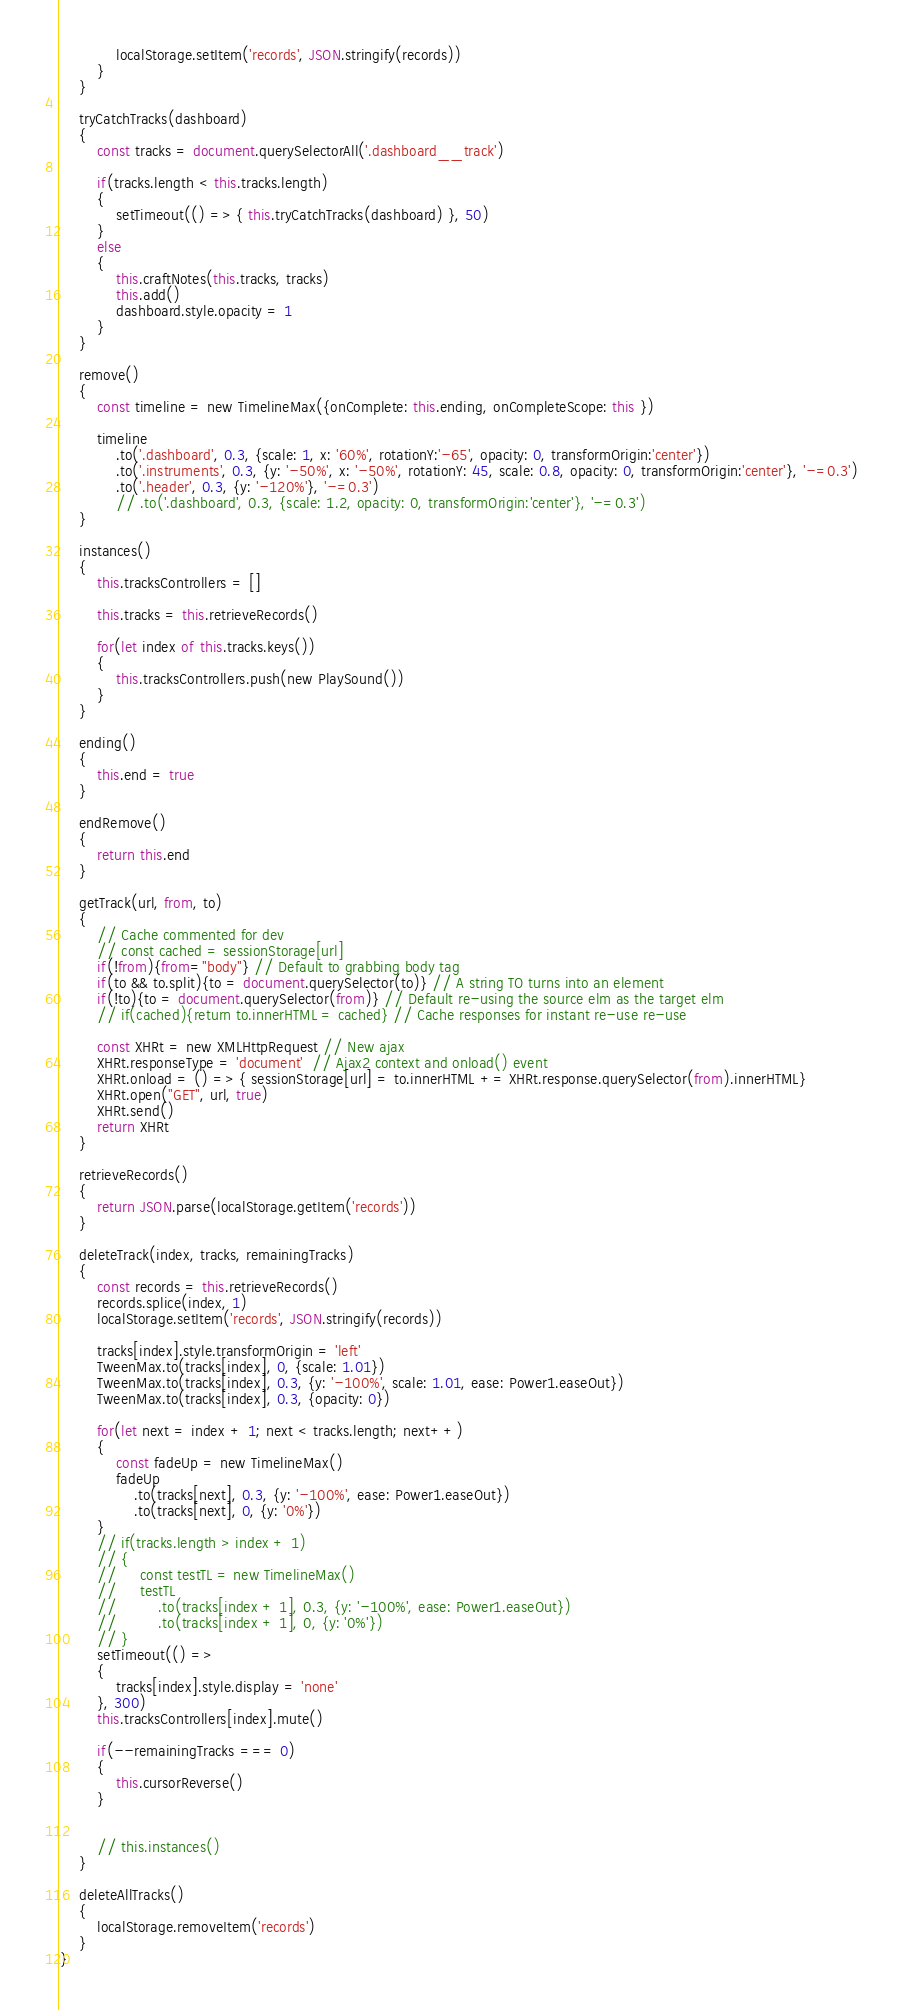Convert code to text. <code><loc_0><loc_0><loc_500><loc_500><_JavaScript_>            localStorage.setItem('records', JSON.stringify(records))
        }
    }

    tryCatchTracks(dashboard)
    {
        const tracks = document.querySelectorAll('.dashboard__track')

        if(tracks.length < this.tracks.length)
        {
            setTimeout(() => { this.tryCatchTracks(dashboard) }, 50)
        }
        else
        {
            this.craftNotes(this.tracks, tracks)
            this.add()
            dashboard.style.opacity = 1
        }
    }

    remove()
    {
        const timeline = new TimelineMax({onComplete: this.ending, onCompleteScope: this })
        
        timeline
            .to('.dashboard', 0.3, {scale: 1, x: '60%', rotationY:'-65', opacity: 0, transformOrigin:'center'})
            .to('.instruments', 0.3, {y: '-50%', x: '-50%', rotationY: 45, scale: 0.8, opacity: 0, transformOrigin:'center'}, '-=0.3')
            .to('.header', 0.3, {y: '-120%'}, '-=0.3')
            // .to('.dashboard', 0.3, {scale: 1.2, opacity: 0, transformOrigin:'center'}, '-=0.3')
    }

    instances()
    {
        this.tracksControllers = []
        
        this.tracks = this.retrieveRecords()

        for(let index of this.tracks.keys())
        {
            this.tracksControllers.push(new PlaySound())
        }
    }

    ending()
    {
        this.end = true
    }

    endRemove()
    {
        return this.end
    }

    getTrack(url, from, to)
	{
		// Cache commented for dev
		// const cached = sessionStorage[url]
		if(!from){from="body"} // Default to grabbing body tag
		if(to && to.split){to = document.querySelector(to)} // A string TO turns into an element
		if(!to){to = document.querySelector(from)} // Default re-using the source elm as the target elm
		// if(cached){return to.innerHTML = cached} // Cache responses for instant re-use re-use

		const XHRt = new XMLHttpRequest // New ajax
		XHRt.responseType = 'document'  // Ajax2 context and onload() event
		XHRt.onload = () => { sessionStorage[url] = to.innerHTML += XHRt.response.querySelector(from).innerHTML}
		XHRt.open("GET", url, true)
		XHRt.send()
		return XHRt
    }

    retrieveRecords()
	{
		return JSON.parse(localStorage.getItem('records'))
    }
    
    deleteTrack(index, tracks, remainingTracks)
    {
        const records = this.retrieveRecords()
        records.splice(index, 1)
        localStorage.setItem('records', JSON.stringify(records))
        
        tracks[index].style.transformOrigin = 'left'
        TweenMax.to(tracks[index], 0, {scale: 1.01})
        TweenMax.to(tracks[index], 0.3, {y: '-100%', scale: 1.01, ease: Power1.easeOut})
        TweenMax.to(tracks[index], 0.3, {opacity: 0})
        
        for(let next = index + 1; next < tracks.length; next++)
        {
            const fadeUp = new TimelineMax()
            fadeUp
                .to(tracks[next], 0.3, {y: '-100%', ease: Power1.easeOut})
                .to(tracks[next], 0, {y: '0%'})
        }
        // if(tracks.length > index + 1)
        // {
        //     const testTL = new TimelineMax()
        //     testTL
        //         .to(tracks[index + 1], 0.3, {y: '-100%', ease: Power1.easeOut})
        //         .to(tracks[index + 1], 0, {y: '0%'})
        // }
        setTimeout(() => 
        {
            tracks[index].style.display = 'none'
        }, 300)
        this.tracksControllers[index].mute()

        if(--remainingTracks === 0)
        {
            this.cursorReverse()
        }

        
        // this.instances()
    }

    deleteAllTracks()
    {
        localStorage.removeItem('records')
    }
}</code> 